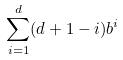<formula> <loc_0><loc_0><loc_500><loc_500>\sum _ { i = 1 } ^ { d } ( d + 1 - i ) b ^ { i }</formula> 